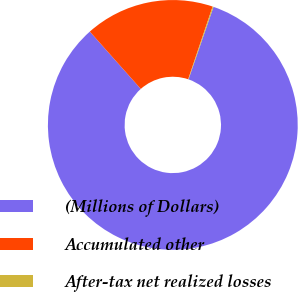Convert chart. <chart><loc_0><loc_0><loc_500><loc_500><pie_chart><fcel>(Millions of Dollars)<fcel>Accumulated other<fcel>After-tax net realized losses<nl><fcel>83.15%<fcel>16.73%<fcel>0.12%<nl></chart> 